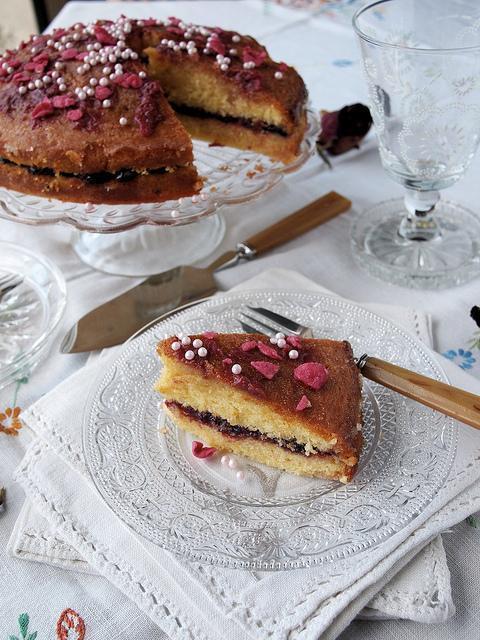What is the filling made of?
From the following set of four choices, select the accurate answer to respond to the question.
Options: Ice cream, frosting, fruit, custard. Fruit. 